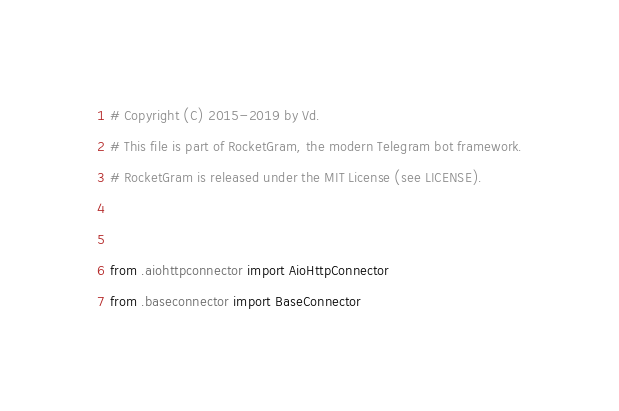Convert code to text. <code><loc_0><loc_0><loc_500><loc_500><_Python_># Copyright (C) 2015-2019 by Vd.
# This file is part of RocketGram, the modern Telegram bot framework.
# RocketGram is released under the MIT License (see LICENSE).


from .aiohttpconnector import AioHttpConnector
from .baseconnector import BaseConnector
</code> 